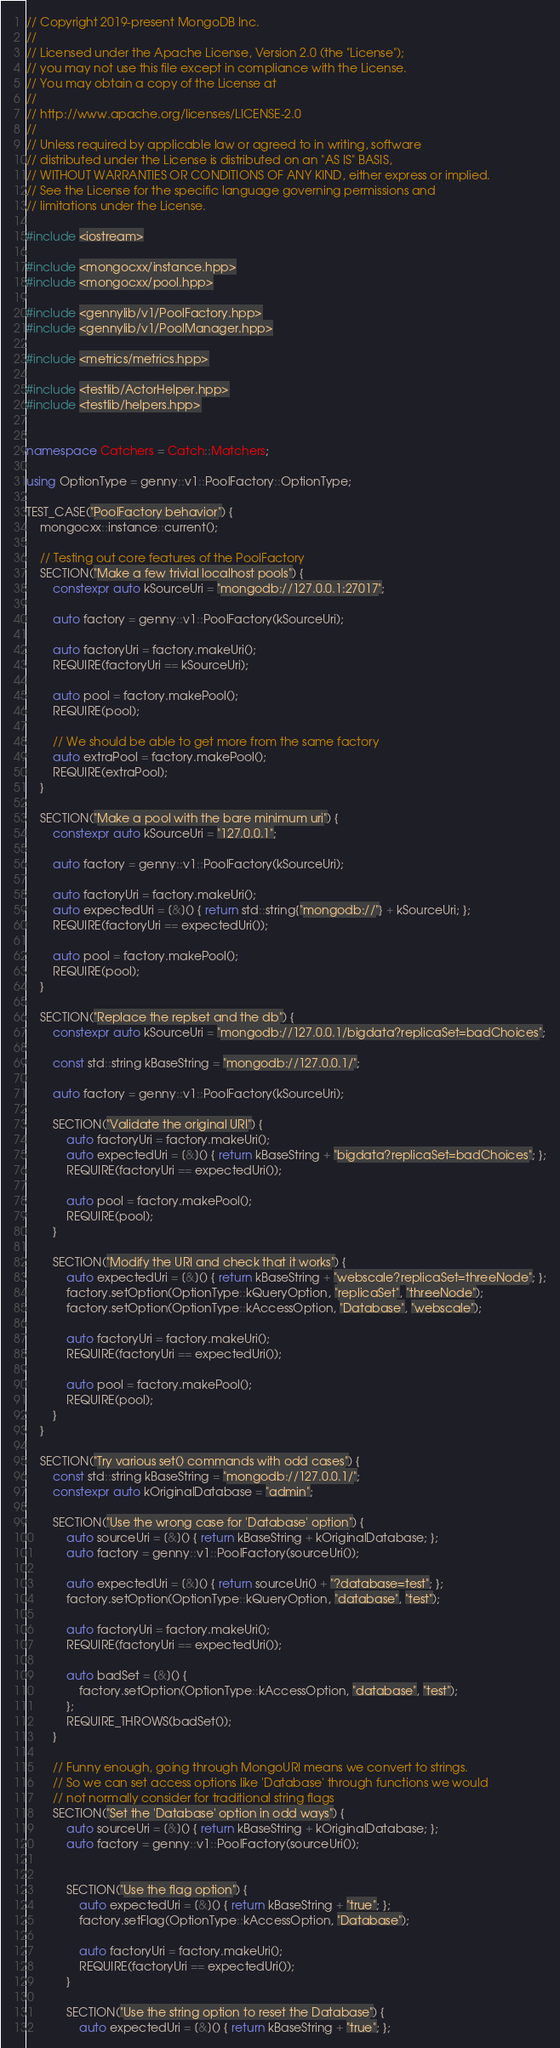Convert code to text. <code><loc_0><loc_0><loc_500><loc_500><_C++_>// Copyright 2019-present MongoDB Inc.
//
// Licensed under the Apache License, Version 2.0 (the "License");
// you may not use this file except in compliance with the License.
// You may obtain a copy of the License at
//
// http://www.apache.org/licenses/LICENSE-2.0
//
// Unless required by applicable law or agreed to in writing, software
// distributed under the License is distributed on an "AS IS" BASIS,
// WITHOUT WARRANTIES OR CONDITIONS OF ANY KIND, either express or implied.
// See the License for the specific language governing permissions and
// limitations under the License.

#include <iostream>

#include <mongocxx/instance.hpp>
#include <mongocxx/pool.hpp>

#include <gennylib/v1/PoolFactory.hpp>
#include <gennylib/v1/PoolManager.hpp>

#include <metrics/metrics.hpp>

#include <testlib/ActorHelper.hpp>
#include <testlib/helpers.hpp>


namespace Catchers = Catch::Matchers;

using OptionType = genny::v1::PoolFactory::OptionType;

TEST_CASE("PoolFactory behavior") {
    mongocxx::instance::current();

    // Testing out core features of the PoolFactory
    SECTION("Make a few trivial localhost pools") {
        constexpr auto kSourceUri = "mongodb://127.0.0.1:27017";

        auto factory = genny::v1::PoolFactory(kSourceUri);

        auto factoryUri = factory.makeUri();
        REQUIRE(factoryUri == kSourceUri);

        auto pool = factory.makePool();
        REQUIRE(pool);

        // We should be able to get more from the same factory
        auto extraPool = factory.makePool();
        REQUIRE(extraPool);
    }

    SECTION("Make a pool with the bare minimum uri") {
        constexpr auto kSourceUri = "127.0.0.1";

        auto factory = genny::v1::PoolFactory(kSourceUri);

        auto factoryUri = factory.makeUri();
        auto expectedUri = [&]() { return std::string{"mongodb://"} + kSourceUri; };
        REQUIRE(factoryUri == expectedUri());

        auto pool = factory.makePool();
        REQUIRE(pool);
    }

    SECTION("Replace the replset and the db") {
        constexpr auto kSourceUri = "mongodb://127.0.0.1/bigdata?replicaSet=badChoices";

        const std::string kBaseString = "mongodb://127.0.0.1/";

        auto factory = genny::v1::PoolFactory(kSourceUri);

        SECTION("Validate the original URI") {
            auto factoryUri = factory.makeUri();
            auto expectedUri = [&]() { return kBaseString + "bigdata?replicaSet=badChoices"; };
            REQUIRE(factoryUri == expectedUri());

            auto pool = factory.makePool();
            REQUIRE(pool);
        }

        SECTION("Modify the URI and check that it works") {
            auto expectedUri = [&]() { return kBaseString + "webscale?replicaSet=threeNode"; };
            factory.setOption(OptionType::kQueryOption, "replicaSet", "threeNode");
            factory.setOption(OptionType::kAccessOption, "Database", "webscale");

            auto factoryUri = factory.makeUri();
            REQUIRE(factoryUri == expectedUri());

            auto pool = factory.makePool();
            REQUIRE(pool);
        }
    }

    SECTION("Try various set() commands with odd cases") {
        const std::string kBaseString = "mongodb://127.0.0.1/";
        constexpr auto kOriginalDatabase = "admin";

        SECTION("Use the wrong case for 'Database' option") {
            auto sourceUri = [&]() { return kBaseString + kOriginalDatabase; };
            auto factory = genny::v1::PoolFactory(sourceUri());

            auto expectedUri = [&]() { return sourceUri() + "?database=test"; };
            factory.setOption(OptionType::kQueryOption, "database", "test");

            auto factoryUri = factory.makeUri();
            REQUIRE(factoryUri == expectedUri());

            auto badSet = [&]() {
                factory.setOption(OptionType::kAccessOption, "database", "test");
            };
            REQUIRE_THROWS(badSet());
        }

        // Funny enough, going through MongoURI means we convert to strings.
        // So we can set access options like 'Database' through functions we would
        // not normally consider for traditional string flags
        SECTION("Set the 'Database' option in odd ways") {
            auto sourceUri = [&]() { return kBaseString + kOriginalDatabase; };
            auto factory = genny::v1::PoolFactory(sourceUri());


            SECTION("Use the flag option") {
                auto expectedUri = [&]() { return kBaseString + "true"; };
                factory.setFlag(OptionType::kAccessOption, "Database");

                auto factoryUri = factory.makeUri();
                REQUIRE(factoryUri == expectedUri());
            }

            SECTION("Use the string option to reset the Database") {
                auto expectedUri = [&]() { return kBaseString + "true"; };</code> 